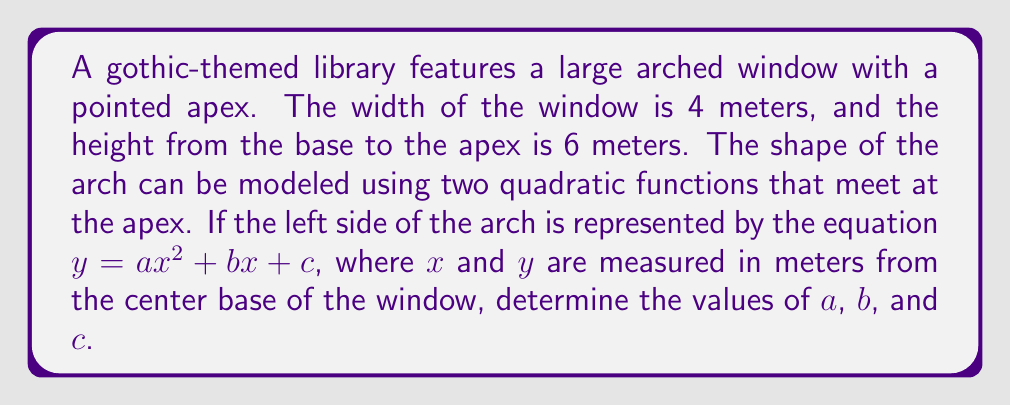Could you help me with this problem? Let's approach this step-by-step:

1) The window is symmetrical, so we only need to focus on the left half of the arch. The right half will be a mirror image.

2) We know three points on this quadratic curve:
   - The base of the left side: (-2, 0)
   - The apex of the arch: (0, 6)
   - The midpoint of the left side: (-1, 3)

3) Let's use these points in the general quadratic equation $y = ax^2 + bx + c$:

   For (-2, 0): $0 = 4a - 2b + c$
   For (0, 6): $6 = c$
   For (-1, 3): $3 = a - b + 6$

4) From the second equation, we immediately know that $c = 6$.

5) Substitute this into the first equation:
   $0 = 4a - 2b + 6$
   $2b = 4a + 6$
   $b = 2a + 3$

6) Now substitute both of these into the third equation:
   $3 = a - (2a + 3) + 6$
   $3 = a - 2a - 3 + 6$
   $0 = -a + 3$
   $a = 3$

7) Now that we know $a$, we can find $b$:
   $b = 2(3) + 3 = 9$

Therefore, the quadratic equation for the left side of the arch is:

$y = 3x^2 + 9x + 6$
Answer: $a = 3$, $b = 9$, $c = 6$ 